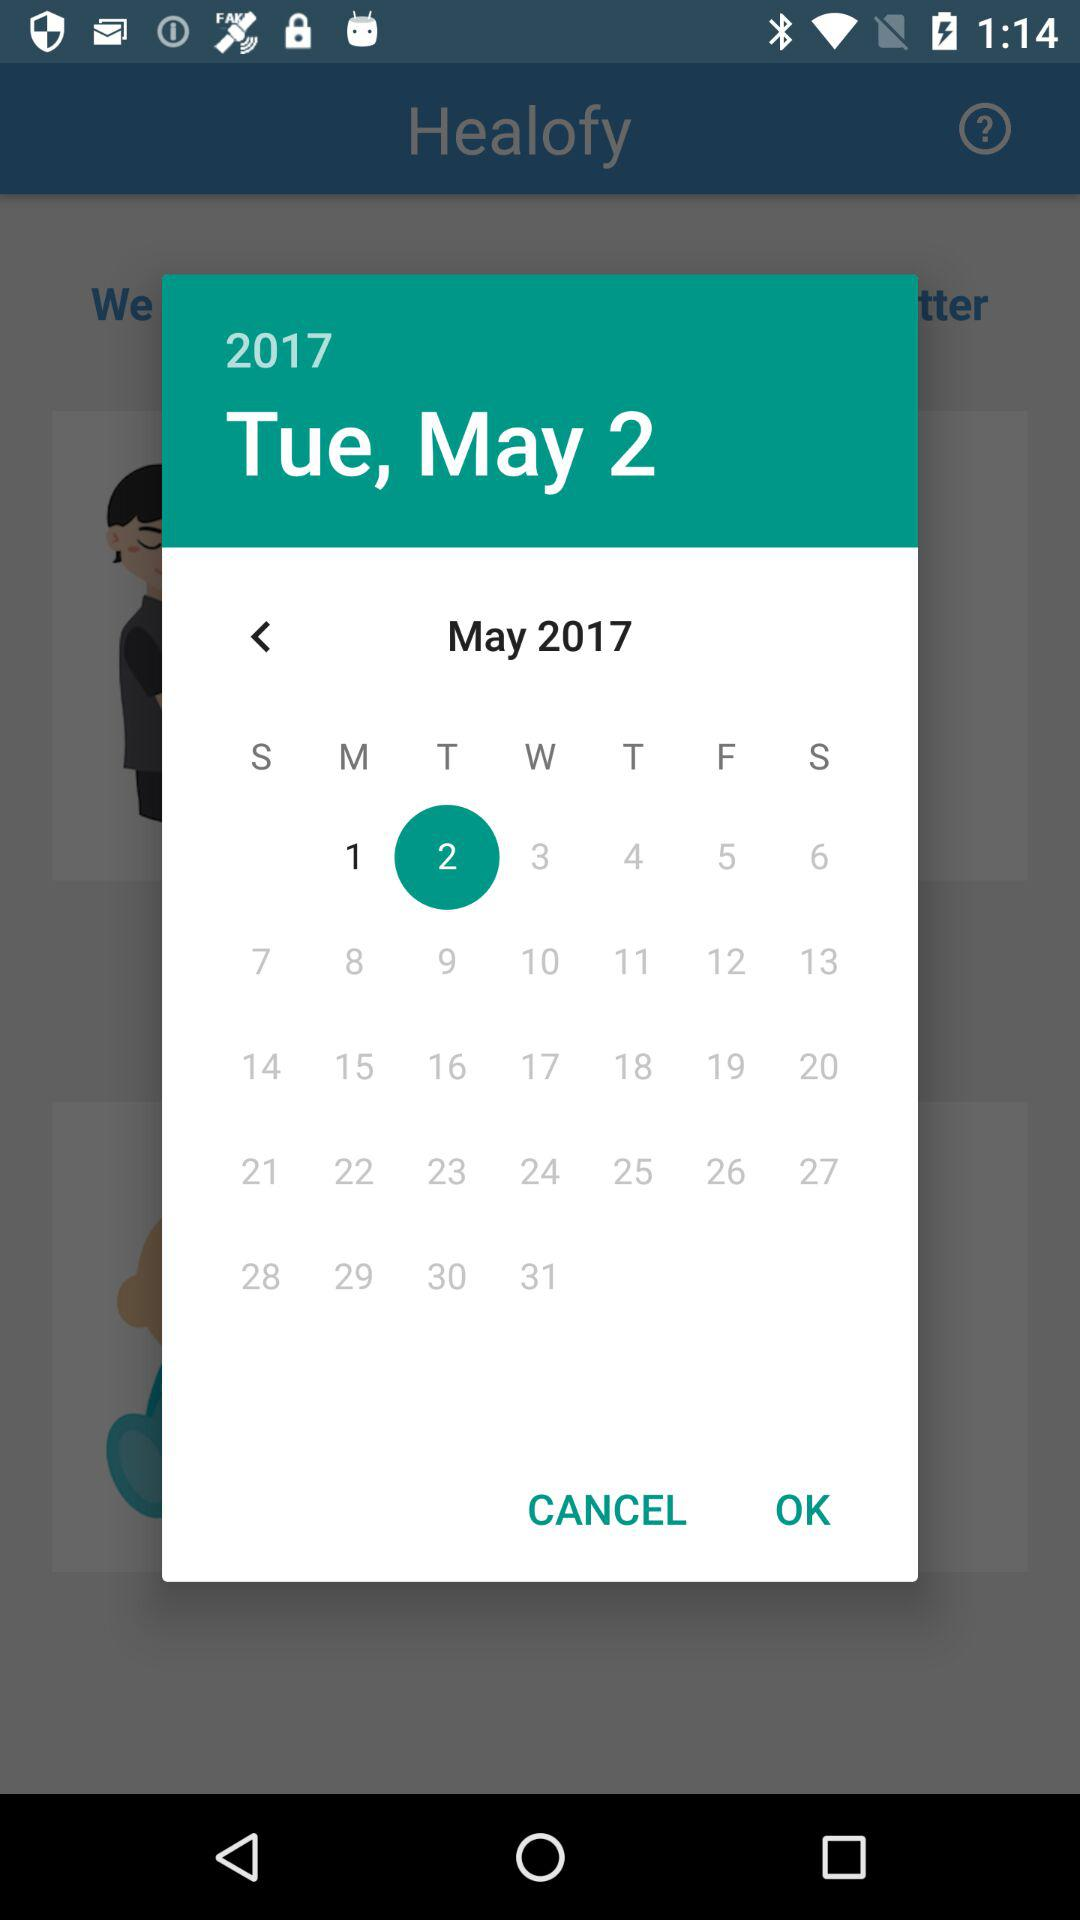What year is mentioned in the calendar? The year mentioned is 2017. 